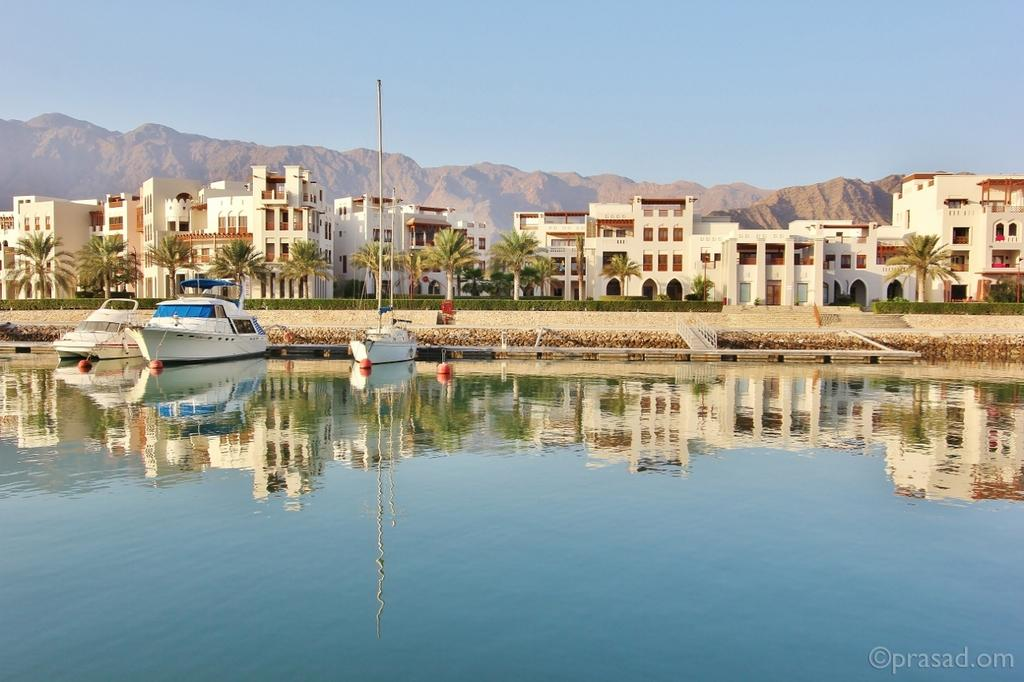What type of structures can be seen in the image? There are buildings in the image. What type of vegetation is present in the image? There are trees in the image. What type of vehicles can be seen in the water in the image? There are boats in the water in the image. What part of the natural environment is visible in the image? The sky is visible in the image. What type of end can be seen in the image? There is no end present in the image. What type of ball is being used in the image? There is no ball present in the image. 